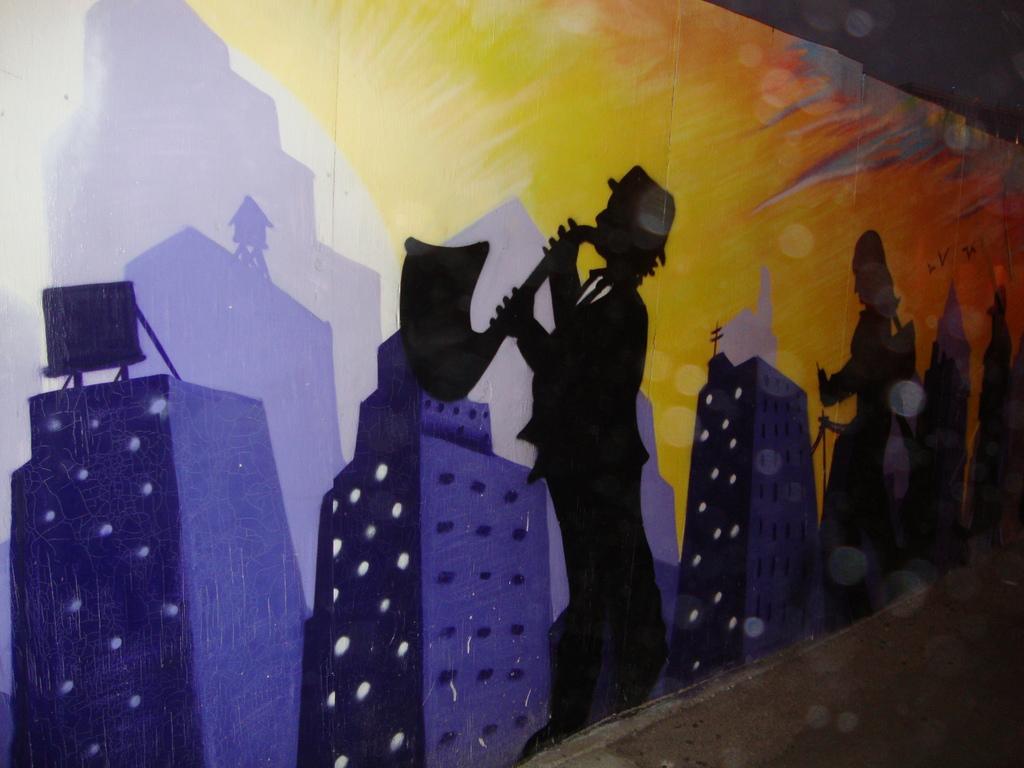In one or two sentences, can you explain what this image depicts? In this image I can see wall paintings on a wall. This image is taken, may be in a hall. 